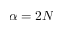Convert formula to latex. <formula><loc_0><loc_0><loc_500><loc_500>\alpha = 2 N</formula> 